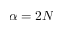Convert formula to latex. <formula><loc_0><loc_0><loc_500><loc_500>\alpha = 2 N</formula> 